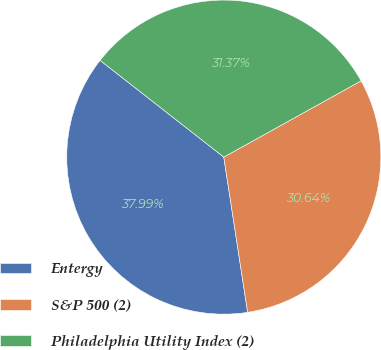Convert chart to OTSL. <chart><loc_0><loc_0><loc_500><loc_500><pie_chart><fcel>Entergy<fcel>S&P 500 (2)<fcel>Philadelphia Utility Index (2)<nl><fcel>37.99%<fcel>30.64%<fcel>31.37%<nl></chart> 